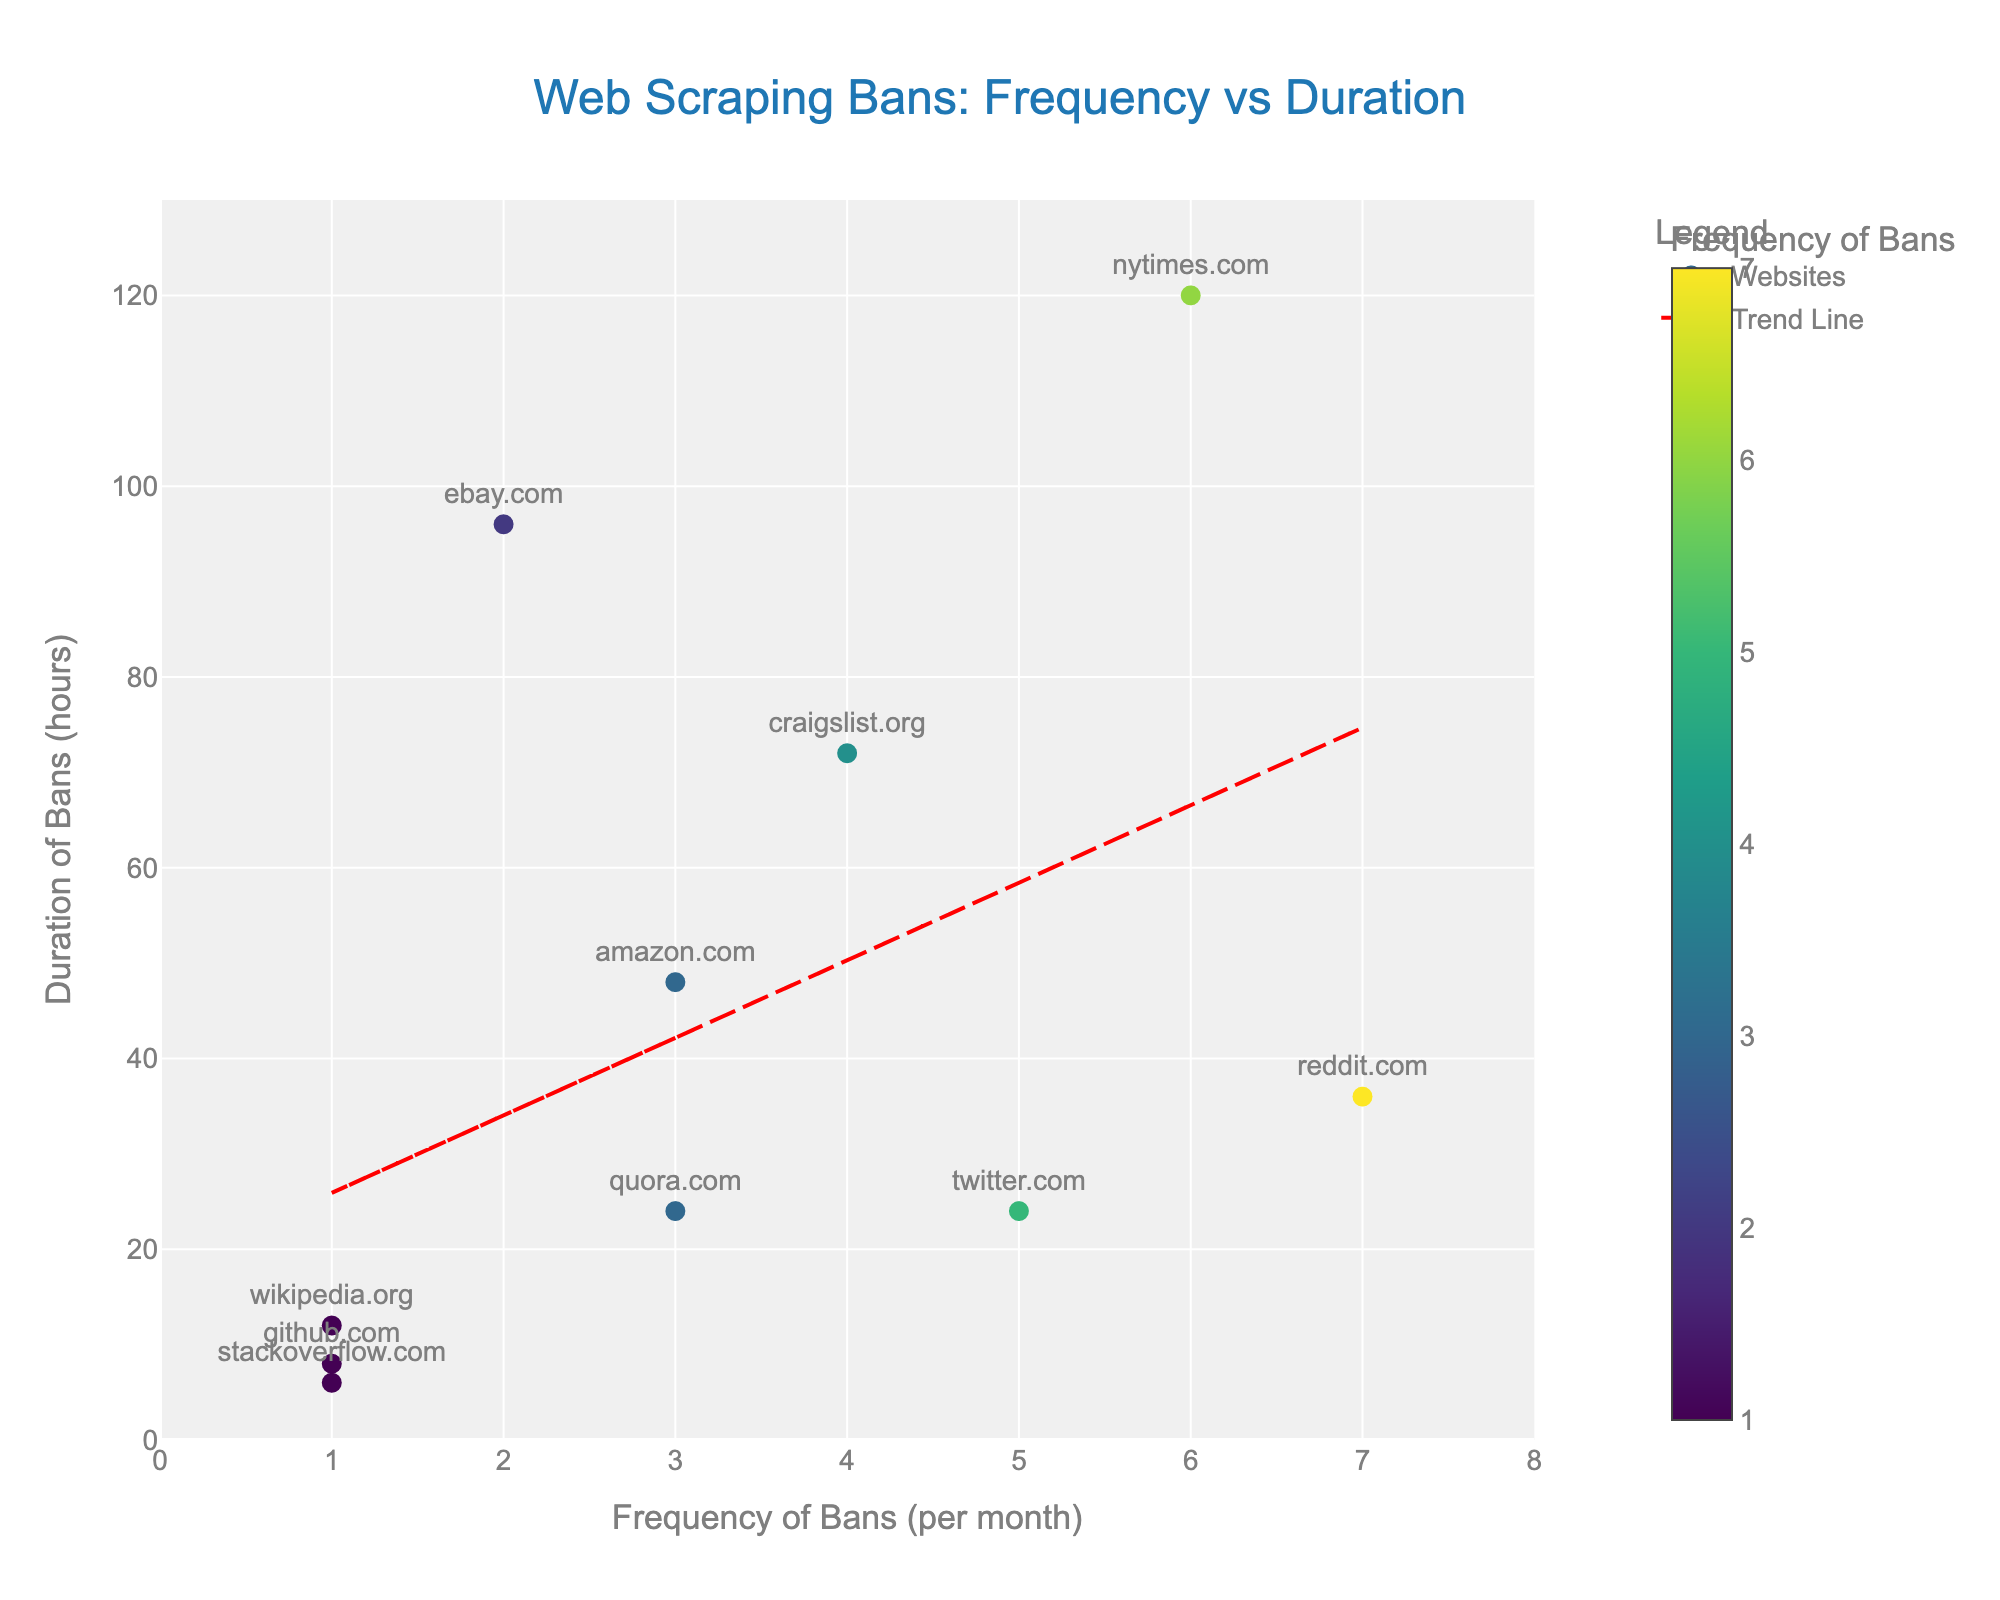What is the title of the figure? The title of the figure is displayed at the top center and it reads "Web Scraping Bans: Frequency vs Duration".
Answer: Web Scraping Bans: Frequency vs Duration Which website has the highest frequency of bans per month? By observing the scatter plot, the website with the highest frequency of bans per month (x-axis) is reddit.com, which is marked at the point 7 on the x-axis.
Answer: reddit.com Which website experiences the longest ban duration? By looking at the y-axis labeled "Duration of Bans (in hours)" and finding the highest point, the website with the longest ban duration is nytimes.com at 120 hours.
Answer: nytimes.com How many websites are plotted in the figure? Count the number of unique data points on the scatter plot. Each data point represents a unique website. There are 10 websites plotted in the figure.
Answer: 10 What is the relationship displayed by the trend line? The trend line in the scatter plot is a red dashed line that shows a positive correlation between the frequency of bans and the duration of bans. This indicates that, generally, as the frequency of bans increases, the duration of bans also tends to increase.
Answer: Positive correlation Which website has a ban duration of 72 hours? Locate the data point at the y-coordinate labeled 72 on the y-axis. The corresponding point on the scatter plot represents craigslist.org.
Answer: craigslist.org What is the average duration of bans for websites with a frequency of bans equal to 1? There are three websites with a frequency of bans equal to 1: wikipedia.org (12 hours), github.com (8 hours), and stackoverflow.com (6 hours). The average duration is calculated as (12 + 8 + 6) / 3 = 26 / 3 ≈ 8.67 hours.
Answer: 8.67 hours Which website has the shortest ban duration, and what is its frequency of bans per month? The shortest ban duration is represented by the lowest point on the y-axis. The website is stackoverflow.com with a duration of 6 hours and a frequency of 1 ban per month.
Answer: stackoverflow.com, 1 Compare the ban duration of twitter.com and quora.com. Which one is higher and by how much? Twitter.com has a ban duration of 24 hours, and quora.com also has a ban duration of 24 hours. The durations are equal, so the difference is 0 hours.
Answer: Equal, 0 hours What is the sum of ban durations for the two websites with the highest frequency of bans? The two websites with the highest frequencies are reddit.com (7 bans) and nytimes.com (6 bans). Their ban durations are 36 hours and 120 hours, respectively. The sum of these durations is 36 + 120 = 156 hours.
Answer: 156 hours If we exclude the maximum ban duration, what is the new average ban duration? Excluding nytimes.com (120 hours), the sum of the remaining ban durations is 48 + 12 + 24 + 72 + 96 + 8 + 6 + 36 + 24 = 326 hours. The number of remaining data points is 9. The new average duration is 326 / 9 ≈ 36.22 hours.
Answer: 36.22 hours 